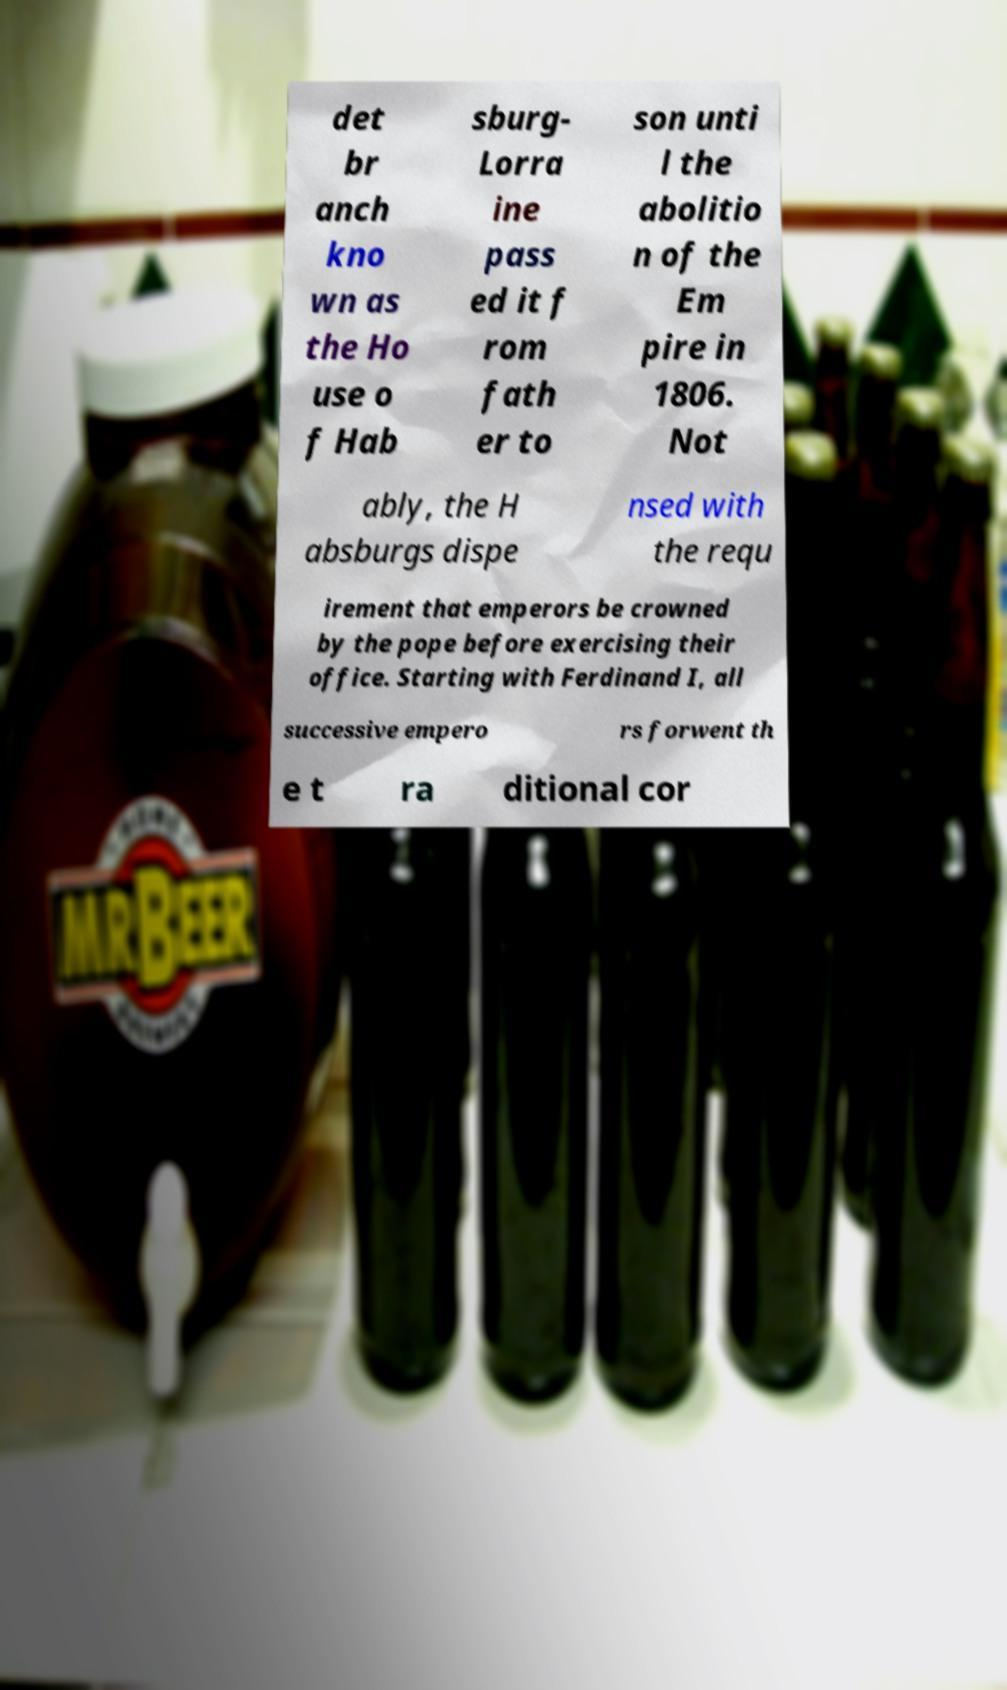For documentation purposes, I need the text within this image transcribed. Could you provide that? det br anch kno wn as the Ho use o f Hab sburg- Lorra ine pass ed it f rom fath er to son unti l the abolitio n of the Em pire in 1806. Not ably, the H absburgs dispe nsed with the requ irement that emperors be crowned by the pope before exercising their office. Starting with Ferdinand I, all successive empero rs forwent th e t ra ditional cor 